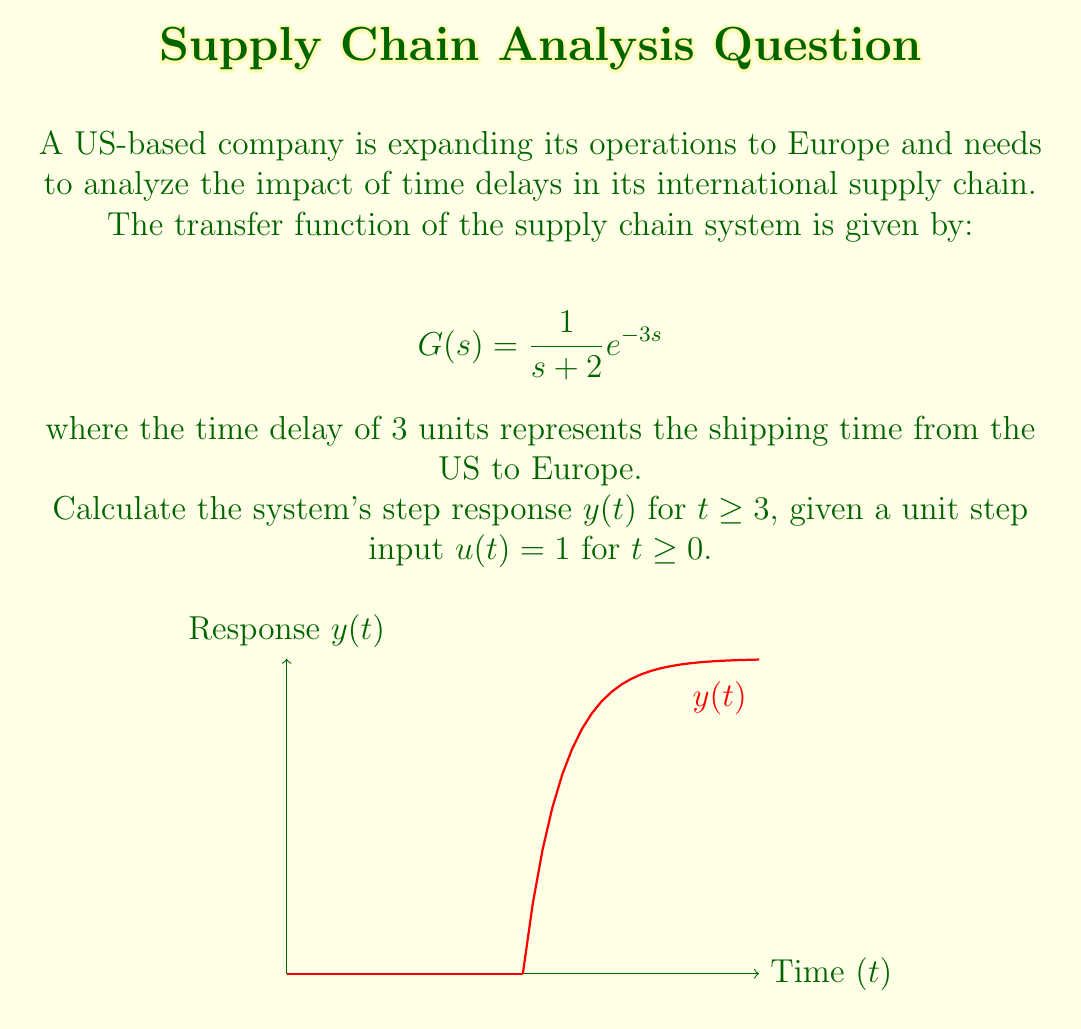Show me your answer to this math problem. To solve this problem, we'll follow these steps:

1) The Laplace transform of the unit step input is $U(s) = \frac{1}{s}$.

2) The output $Y(s)$ in the Laplace domain is:

   $$Y(s) = G(s)U(s) = \frac{1}{s + 2}e^{-3s} \cdot \frac{1}{s} = \frac{1}{s(s+2)}e^{-3s}$$

3) To find $y(t)$, we need to take the inverse Laplace transform of $Y(s)$. The time delay $e^{-3s}$ in the Laplace domain corresponds to a time shift of 3 units in the time domain.

4) Without the delay, the inverse Laplace transform would be:

   $$\mathcal{L}^{-1}\{\frac{1}{s(s+2)}\} = 1 - e^{-2t}$$

5) Incorporating the time delay, we get:

   $$y(t) = \begin{cases} 
   0 & \text{for } 0 \leq t < 3 \\
   1 - e^{-2(t-3)} & \text{for } t \geq 3
   \end{cases}$$

6) This result shows that the system doesn't respond for the first 3 time units (due to shipping delay), and then follows an exponential approach to the steady-state value of 1.
Answer: $$y(t) = \begin{cases} 
0 & \text{for } 0 \leq t < 3 \\
1 - e^{-2(t-3)} & \text{for } t \geq 3
\end{cases}$$ 